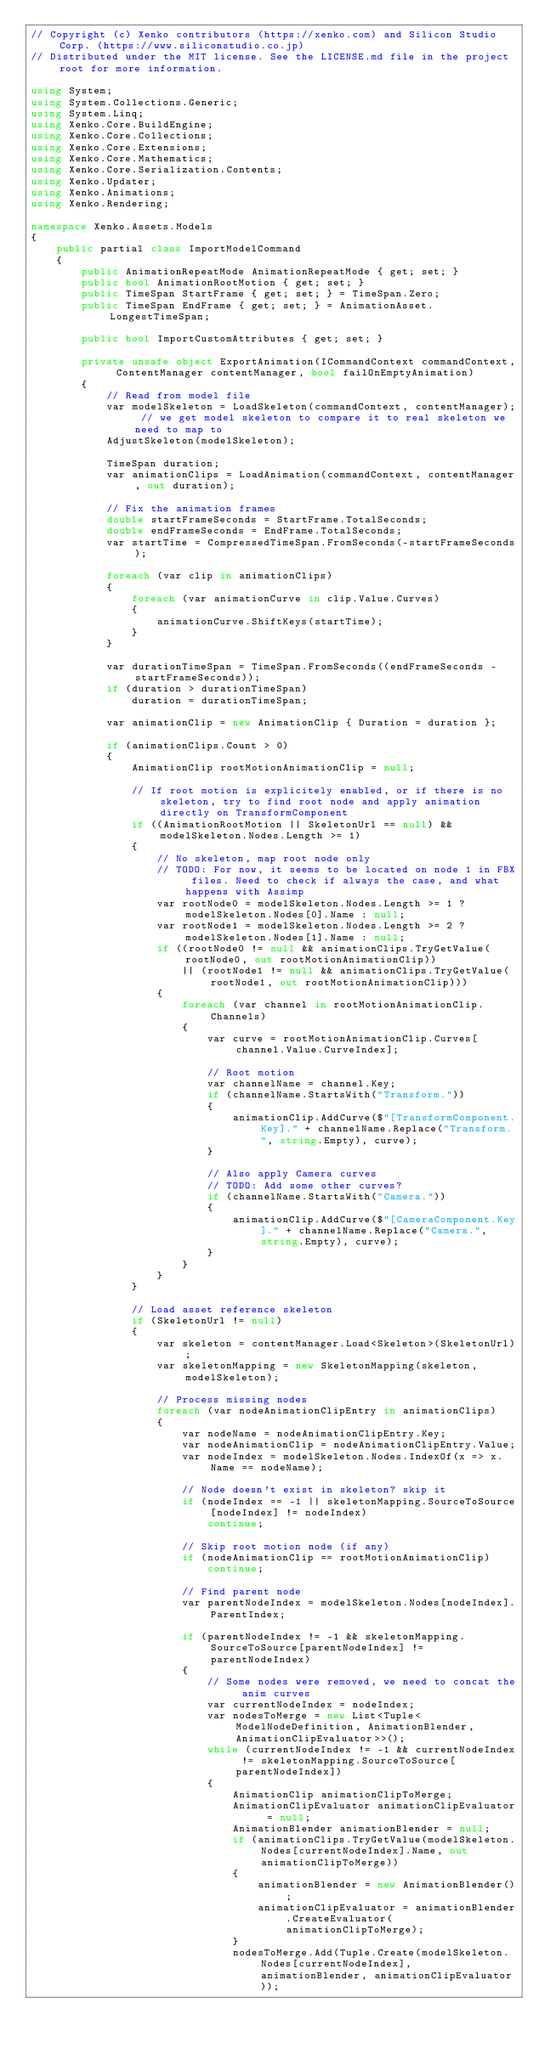<code> <loc_0><loc_0><loc_500><loc_500><_C#_>// Copyright (c) Xenko contributors (https://xenko.com) and Silicon Studio Corp. (https://www.siliconstudio.co.jp)
// Distributed under the MIT license. See the LICENSE.md file in the project root for more information.

using System;
using System.Collections.Generic;
using System.Linq;
using Xenko.Core.BuildEngine;
using Xenko.Core.Collections;
using Xenko.Core.Extensions;
using Xenko.Core.Mathematics;
using Xenko.Core.Serialization.Contents;
using Xenko.Updater;
using Xenko.Animations;
using Xenko.Rendering;

namespace Xenko.Assets.Models
{
    public partial class ImportModelCommand
    {
        public AnimationRepeatMode AnimationRepeatMode { get; set; }
        public bool AnimationRootMotion { get; set; }
        public TimeSpan StartFrame { get; set; } = TimeSpan.Zero;
        public TimeSpan EndFrame { get; set; } = AnimationAsset.LongestTimeSpan;

        public bool ImportCustomAttributes { get; set; }

        private unsafe object ExportAnimation(ICommandContext commandContext, ContentManager contentManager, bool failOnEmptyAnimation)
        {
            // Read from model file
            var modelSkeleton = LoadSkeleton(commandContext, contentManager); // we get model skeleton to compare it to real skeleton we need to map to
            AdjustSkeleton(modelSkeleton);

            TimeSpan duration;
            var animationClips = LoadAnimation(commandContext, contentManager, out duration);

            // Fix the animation frames
            double startFrameSeconds = StartFrame.TotalSeconds;
            double endFrameSeconds = EndFrame.TotalSeconds;
            var startTime = CompressedTimeSpan.FromSeconds(-startFrameSeconds);

            foreach (var clip in animationClips)
            {
                foreach (var animationCurve in clip.Value.Curves)
                {
                    animationCurve.ShiftKeys(startTime);
                }
            }

            var durationTimeSpan = TimeSpan.FromSeconds((endFrameSeconds - startFrameSeconds));
            if (duration > durationTimeSpan)
                duration = durationTimeSpan;

            var animationClip = new AnimationClip { Duration = duration };

            if (animationClips.Count > 0)
            {
                AnimationClip rootMotionAnimationClip = null;

                // If root motion is explicitely enabled, or if there is no skeleton, try to find root node and apply animation directly on TransformComponent
                if ((AnimationRootMotion || SkeletonUrl == null) && modelSkeleton.Nodes.Length >= 1)
                {
                    // No skeleton, map root node only
                    // TODO: For now, it seems to be located on node 1 in FBX files. Need to check if always the case, and what happens with Assimp
                    var rootNode0 = modelSkeleton.Nodes.Length >= 1 ? modelSkeleton.Nodes[0].Name : null;
                    var rootNode1 = modelSkeleton.Nodes.Length >= 2 ? modelSkeleton.Nodes[1].Name : null;
                    if ((rootNode0 != null && animationClips.TryGetValue(rootNode0, out rootMotionAnimationClip))
                        || (rootNode1 != null && animationClips.TryGetValue(rootNode1, out rootMotionAnimationClip)))
                    {
                        foreach (var channel in rootMotionAnimationClip.Channels)
                        {
                            var curve = rootMotionAnimationClip.Curves[channel.Value.CurveIndex];

                            // Root motion
                            var channelName = channel.Key;
                            if (channelName.StartsWith("Transform."))
                            {
                                animationClip.AddCurve($"[TransformComponent.Key]." + channelName.Replace("Transform.", string.Empty), curve);
                            }

                            // Also apply Camera curves
                            // TODO: Add some other curves?
                            if (channelName.StartsWith("Camera."))
                            {
                                animationClip.AddCurve($"[CameraComponent.Key]." + channelName.Replace("Camera.", string.Empty), curve);
                            }
                        }
                    }
                }

                // Load asset reference skeleton
                if (SkeletonUrl != null)
                {
                    var skeleton = contentManager.Load<Skeleton>(SkeletonUrl);
                    var skeletonMapping = new SkeletonMapping(skeleton, modelSkeleton);

                    // Process missing nodes
                    foreach (var nodeAnimationClipEntry in animationClips)
                    {
                        var nodeName = nodeAnimationClipEntry.Key;
                        var nodeAnimationClip = nodeAnimationClipEntry.Value;
                        var nodeIndex = modelSkeleton.Nodes.IndexOf(x => x.Name == nodeName);

                        // Node doesn't exist in skeleton? skip it
                        if (nodeIndex == -1 || skeletonMapping.SourceToSource[nodeIndex] != nodeIndex)
                            continue;

                        // Skip root motion node (if any)
                        if (nodeAnimationClip == rootMotionAnimationClip)
                            continue;

                        // Find parent node
                        var parentNodeIndex = modelSkeleton.Nodes[nodeIndex].ParentIndex;

                        if (parentNodeIndex != -1 && skeletonMapping.SourceToSource[parentNodeIndex] != parentNodeIndex)
                        {
                            // Some nodes were removed, we need to concat the anim curves
                            var currentNodeIndex = nodeIndex;
                            var nodesToMerge = new List<Tuple<ModelNodeDefinition, AnimationBlender, AnimationClipEvaluator>>();
                            while (currentNodeIndex != -1 && currentNodeIndex != skeletonMapping.SourceToSource[parentNodeIndex])
                            {
                                AnimationClip animationClipToMerge;
                                AnimationClipEvaluator animationClipEvaluator = null;
                                AnimationBlender animationBlender = null;
                                if (animationClips.TryGetValue(modelSkeleton.Nodes[currentNodeIndex].Name, out animationClipToMerge))
                                {
                                    animationBlender = new AnimationBlender();
                                    animationClipEvaluator = animationBlender.CreateEvaluator(animationClipToMerge);
                                }
                                nodesToMerge.Add(Tuple.Create(modelSkeleton.Nodes[currentNodeIndex], animationBlender, animationClipEvaluator));</code> 